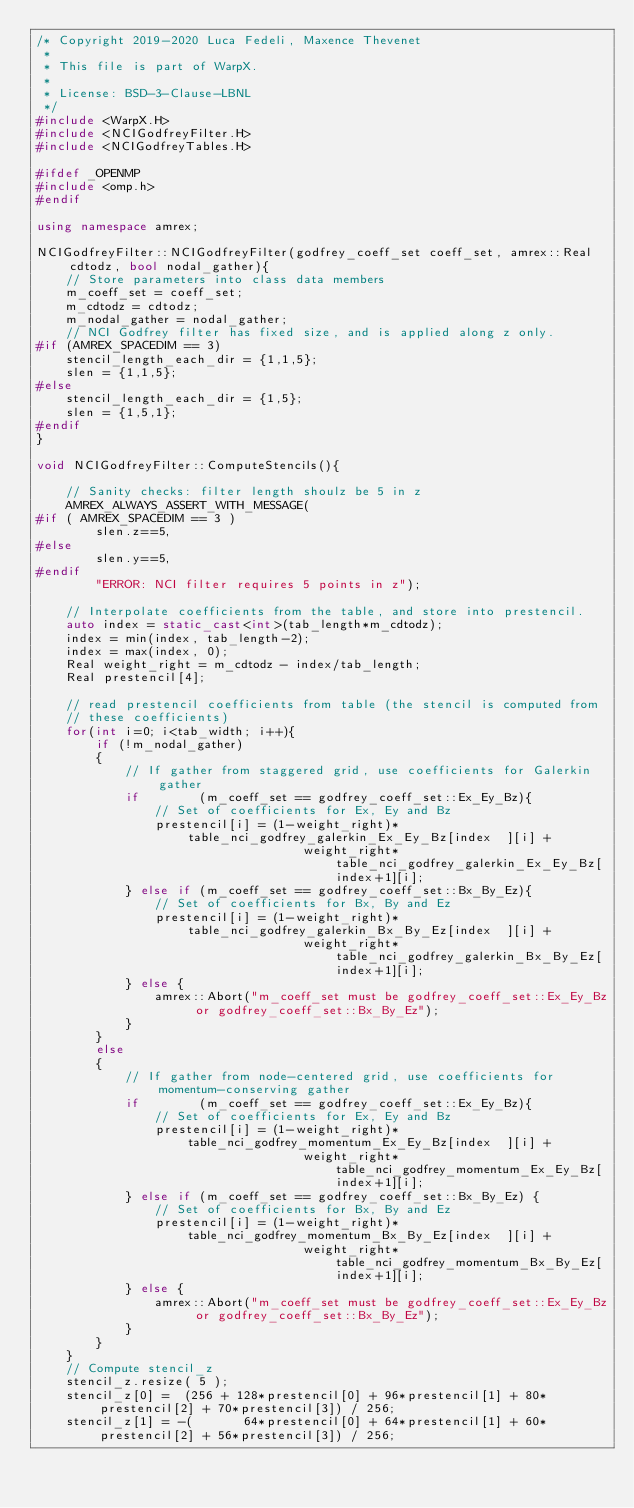Convert code to text. <code><loc_0><loc_0><loc_500><loc_500><_C++_>/* Copyright 2019-2020 Luca Fedeli, Maxence Thevenet
 *
 * This file is part of WarpX.
 *
 * License: BSD-3-Clause-LBNL
 */
#include <WarpX.H>
#include <NCIGodfreyFilter.H>
#include <NCIGodfreyTables.H>

#ifdef _OPENMP
#include <omp.h>
#endif

using namespace amrex;

NCIGodfreyFilter::NCIGodfreyFilter(godfrey_coeff_set coeff_set, amrex::Real cdtodz, bool nodal_gather){
    // Store parameters into class data members
    m_coeff_set = coeff_set;
    m_cdtodz = cdtodz;
    m_nodal_gather = nodal_gather;
    // NCI Godfrey filter has fixed size, and is applied along z only.
#if (AMREX_SPACEDIM == 3)
    stencil_length_each_dir = {1,1,5};
    slen = {1,1,5};
#else
    stencil_length_each_dir = {1,5};
    slen = {1,5,1};
#endif
}

void NCIGodfreyFilter::ComputeStencils(){

    // Sanity checks: filter length shoulz be 5 in z
    AMREX_ALWAYS_ASSERT_WITH_MESSAGE(
#if ( AMREX_SPACEDIM == 3 )
        slen.z==5,
#else
        slen.y==5,
#endif
        "ERROR: NCI filter requires 5 points in z");

    // Interpolate coefficients from the table, and store into prestencil.
    auto index = static_cast<int>(tab_length*m_cdtodz);
    index = min(index, tab_length-2);
    index = max(index, 0);
    Real weight_right = m_cdtodz - index/tab_length;
    Real prestencil[4];

    // read prestencil coefficients from table (the stencil is computed from
    // these coefficients)
    for(int i=0; i<tab_width; i++){
        if (!m_nodal_gather)
        {
            // If gather from staggered grid, use coefficients for Galerkin gather
            if        (m_coeff_set == godfrey_coeff_set::Ex_Ey_Bz){
                // Set of coefficients for Ex, Ey and Bz
                prestencil[i] = (1-weight_right)*table_nci_godfrey_galerkin_Ex_Ey_Bz[index  ][i] +
                                    weight_right*table_nci_godfrey_galerkin_Ex_Ey_Bz[index+1][i];
            } else if (m_coeff_set == godfrey_coeff_set::Bx_By_Ez){
                // Set of coefficients for Bx, By and Ez
                prestencil[i] = (1-weight_right)*table_nci_godfrey_galerkin_Bx_By_Ez[index  ][i] +
                                    weight_right*table_nci_godfrey_galerkin_Bx_By_Ez[index+1][i];
            } else {
                amrex::Abort("m_coeff_set must be godfrey_coeff_set::Ex_Ey_Bz or godfrey_coeff_set::Bx_By_Ez");
            }
        }
        else
        {
            // If gather from node-centered grid, use coefficients for momentum-conserving gather
            if        (m_coeff_set == godfrey_coeff_set::Ex_Ey_Bz){
                // Set of coefficients for Ex, Ey and Bz
                prestencil[i] = (1-weight_right)*table_nci_godfrey_momentum_Ex_Ey_Bz[index  ][i] +
                                    weight_right*table_nci_godfrey_momentum_Ex_Ey_Bz[index+1][i];
            } else if (m_coeff_set == godfrey_coeff_set::Bx_By_Ez) {
                // Set of coefficients for Bx, By and Ez
                prestencil[i] = (1-weight_right)*table_nci_godfrey_momentum_Bx_By_Ez[index  ][i] +
                                    weight_right*table_nci_godfrey_momentum_Bx_By_Ez[index+1][i];
            } else {
                amrex::Abort("m_coeff_set must be godfrey_coeff_set::Ex_Ey_Bz or godfrey_coeff_set::Bx_By_Ez");
            }
        }
    }
    // Compute stencil_z
    stencil_z.resize( 5 );
    stencil_z[0] =  (256 + 128*prestencil[0] + 96*prestencil[1] + 80*prestencil[2] + 70*prestencil[3]) / 256;
    stencil_z[1] = -(       64*prestencil[0] + 64*prestencil[1] + 60*prestencil[2] + 56*prestencil[3]) / 256;</code> 